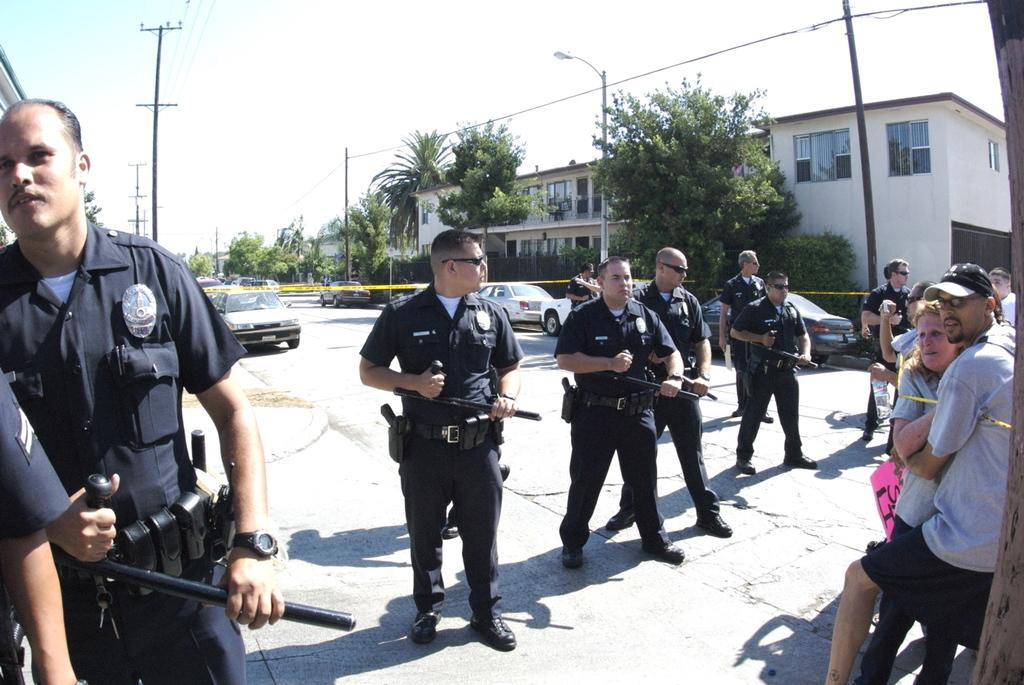What can be seen in the image in terms of people? There are groups of people in the image. What type of vehicles are present in the image? There are cars in the image. What information is displayed in the image? Current polls are present in the image. What type of lighting is visible in the image? Street lamps are visible in the image. What type of structures are present in the image? There are buildings in the image. What part of the natural environment is visible in the image? The sky is visible in the image. Are there any friends playing in the snow in the image? There is no mention of friends or snow in the image; it features groups of people, cars, current polls, street lamps, buildings, and the sky. How many rings can be seen on the fingers of the people in the image? There is no indication of rings on the fingers of the people in the image. 